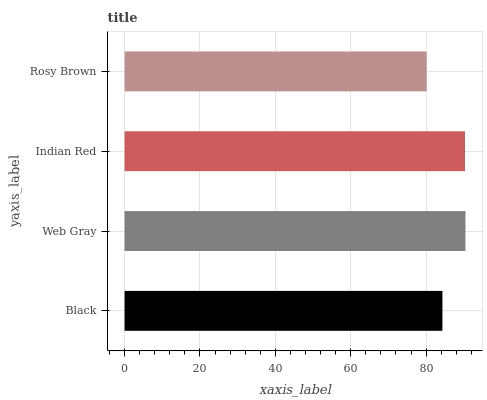Is Rosy Brown the minimum?
Answer yes or no. Yes. Is Web Gray the maximum?
Answer yes or no. Yes. Is Indian Red the minimum?
Answer yes or no. No. Is Indian Red the maximum?
Answer yes or no. No. Is Web Gray greater than Indian Red?
Answer yes or no. Yes. Is Indian Red less than Web Gray?
Answer yes or no. Yes. Is Indian Red greater than Web Gray?
Answer yes or no. No. Is Web Gray less than Indian Red?
Answer yes or no. No. Is Indian Red the high median?
Answer yes or no. Yes. Is Black the low median?
Answer yes or no. Yes. Is Web Gray the high median?
Answer yes or no. No. Is Rosy Brown the low median?
Answer yes or no. No. 